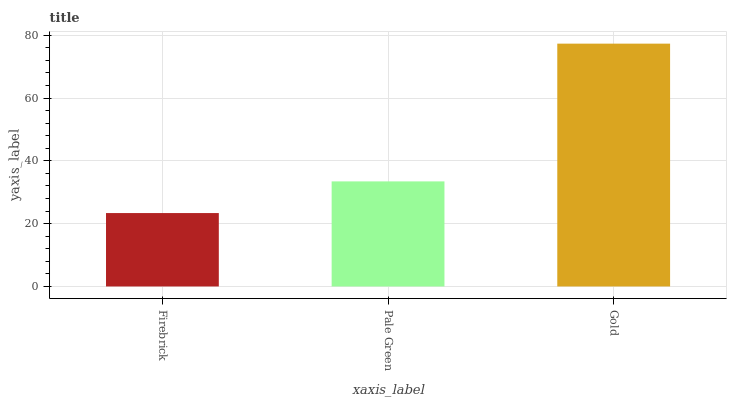Is Firebrick the minimum?
Answer yes or no. Yes. Is Gold the maximum?
Answer yes or no. Yes. Is Pale Green the minimum?
Answer yes or no. No. Is Pale Green the maximum?
Answer yes or no. No. Is Pale Green greater than Firebrick?
Answer yes or no. Yes. Is Firebrick less than Pale Green?
Answer yes or no. Yes. Is Firebrick greater than Pale Green?
Answer yes or no. No. Is Pale Green less than Firebrick?
Answer yes or no. No. Is Pale Green the high median?
Answer yes or no. Yes. Is Pale Green the low median?
Answer yes or no. Yes. Is Gold the high median?
Answer yes or no. No. Is Firebrick the low median?
Answer yes or no. No. 